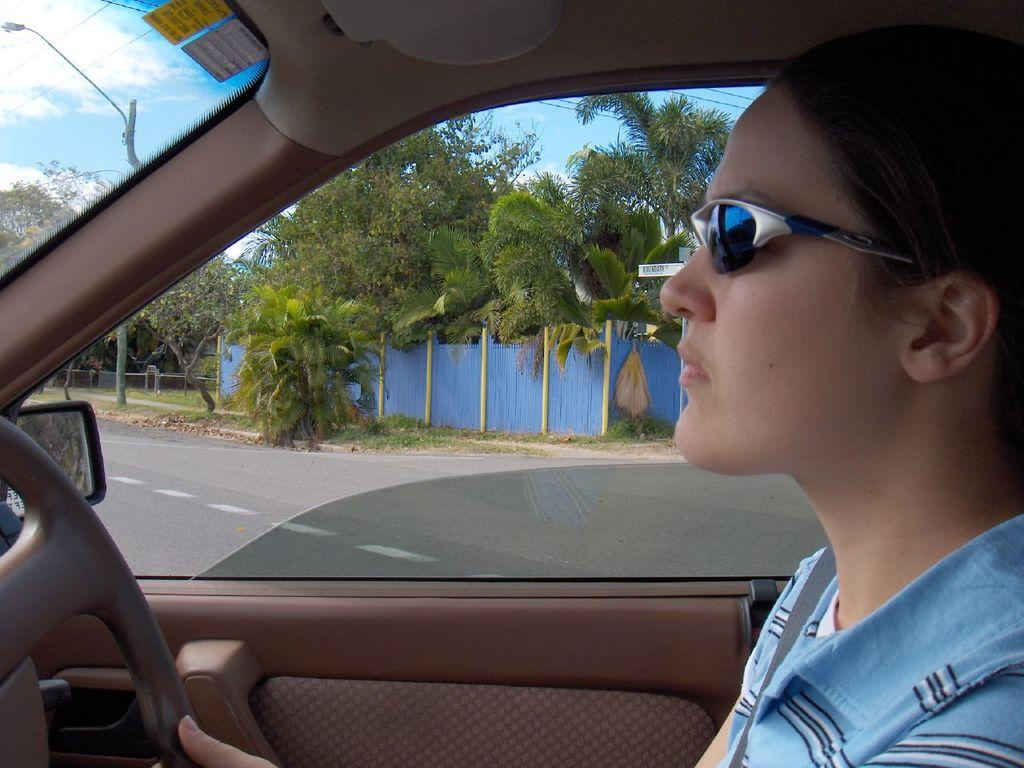What is the person in the image doing? The person is riding a car in the image. What protective gear is the person wearing? The person is wearing goggles. Where is the car located? The car is on the road. What can be seen at the back of the image? There are blue fencing and trees at the back. What time does the clock in the image show? There is no clock present in the image. How many heads of lettuce can be seen in the image? There is no lettuce present in the image. 